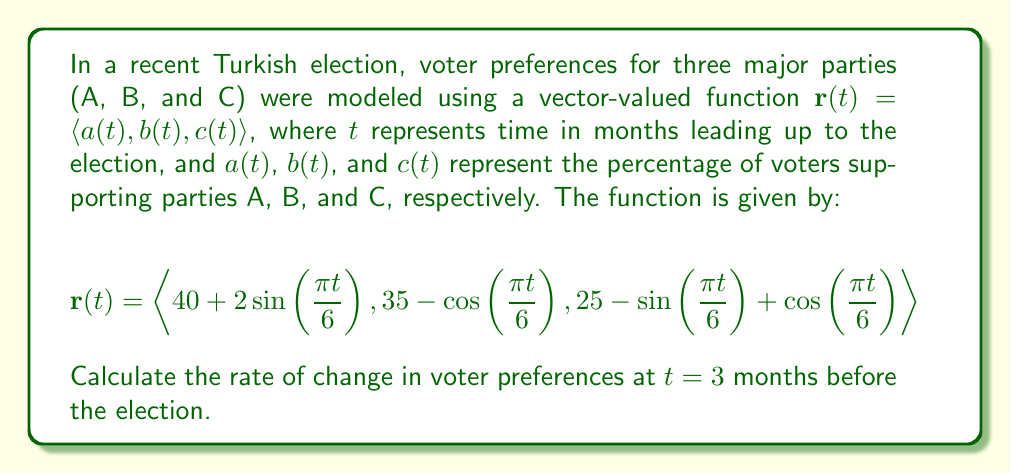Provide a solution to this math problem. To solve this problem, we need to follow these steps:

1) First, we need to find the derivative of the vector-valued function $\mathbf{r}(t)$. This will give us the rate of change of voter preferences.

2) The derivative of $\mathbf{r}(t)$ is:

   $$\mathbf{r}'(t) = \langle a'(t), b'(t), c'(t) \rangle$$

3) Let's calculate each component:

   $a'(t) = 2\cos(\frac{\pi t}{6}) \cdot \frac{\pi}{6}$
   
   $b'(t) = \sin(\frac{\pi t}{6}) \cdot \frac{\pi}{6}$
   
   $c'(t) = -\cos(\frac{\pi t}{6}) \cdot \frac{\pi}{6} - \sin(\frac{\pi t}{6}) \cdot \frac{\pi}{6}$

4) Now, we need to evaluate this at $t = 3$:

   $a'(3) = 2\cos(\frac{\pi}{2}) \cdot \frac{\pi}{6} = 0$
   
   $b'(3) = \sin(\frac{\pi}{2}) \cdot \frac{\pi}{6} = \frac{\pi}{6}$
   
   $c'(3) = -\cos(\frac{\pi}{2}) \cdot \frac{\pi}{6} - \sin(\frac{\pi}{2}) \cdot \frac{\pi}{6} = -\frac{\pi}{6}$

5) Therefore, the rate of change at $t = 3$ is:

   $$\mathbf{r}'(3) = \langle 0, \frac{\pi}{6}, -\frac{\pi}{6} \rangle$$

This vector represents the instantaneous rate of change in voter preferences for each party at 3 months before the election.
Answer: $$\mathbf{r}'(3) = \langle 0, \frac{\pi}{6}, -\frac{\pi}{6} \rangle$$ 